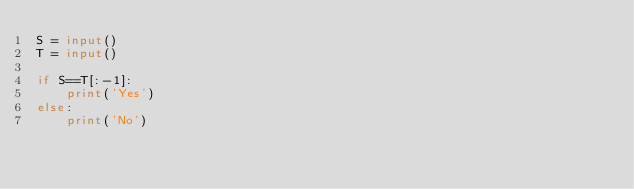Convert code to text. <code><loc_0><loc_0><loc_500><loc_500><_Python_>S = input()
T = input()

if S==T[:-1]:
    print('Yes')
else:
    print('No')</code> 